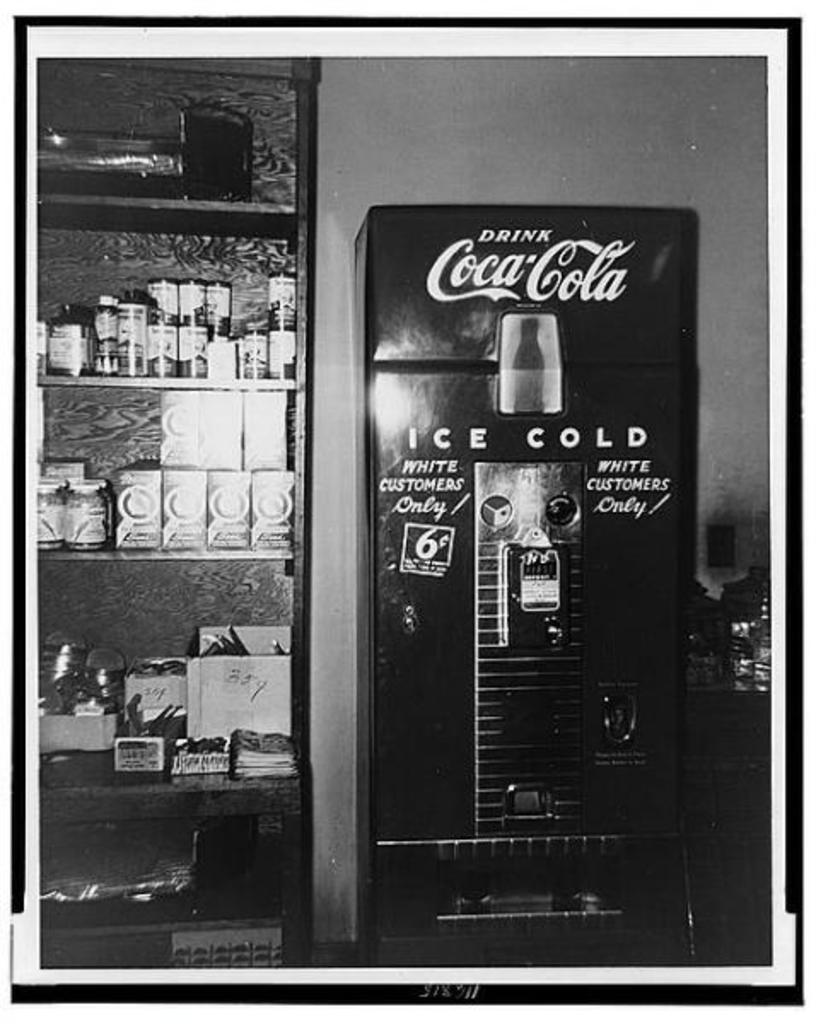<image>
Provide a brief description of the given image. a black and white photo of a drink coca-cola machine 